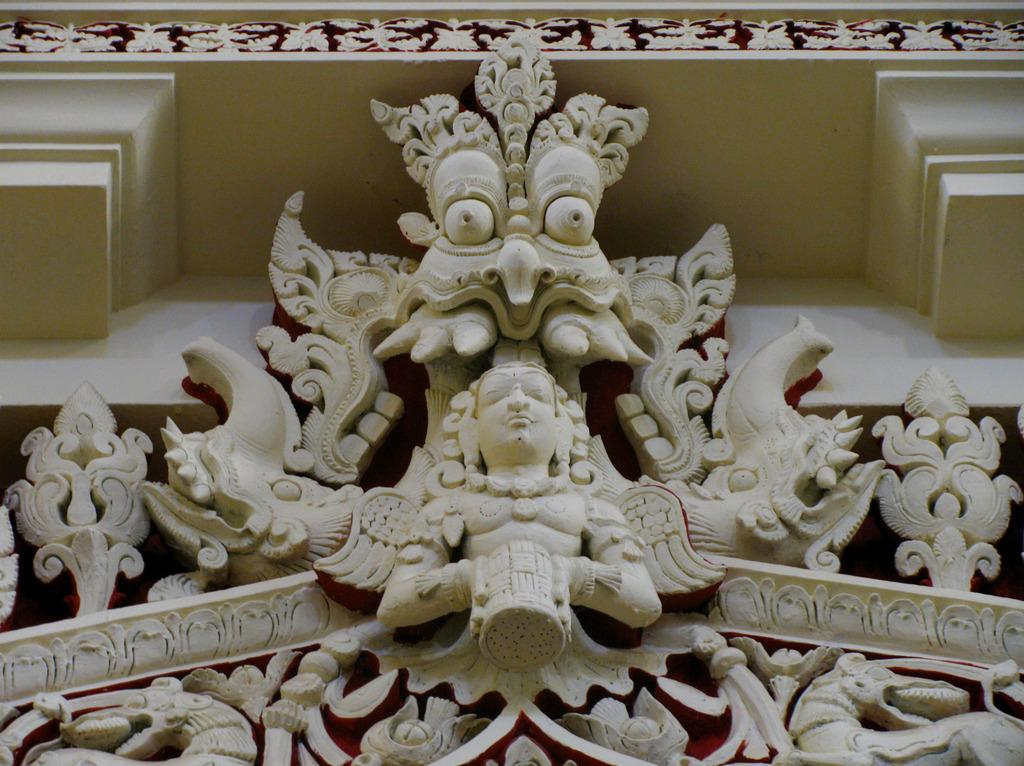What is the main subject of the image? The main subject of the image is a sculpture on a building. What can be seen at the top of the building? There are floral designs at the top of the building. What type of meat is being cooked in the image? There is no meat or cooking activity present in the image; it features a sculpture on a building with floral designs at the top. 